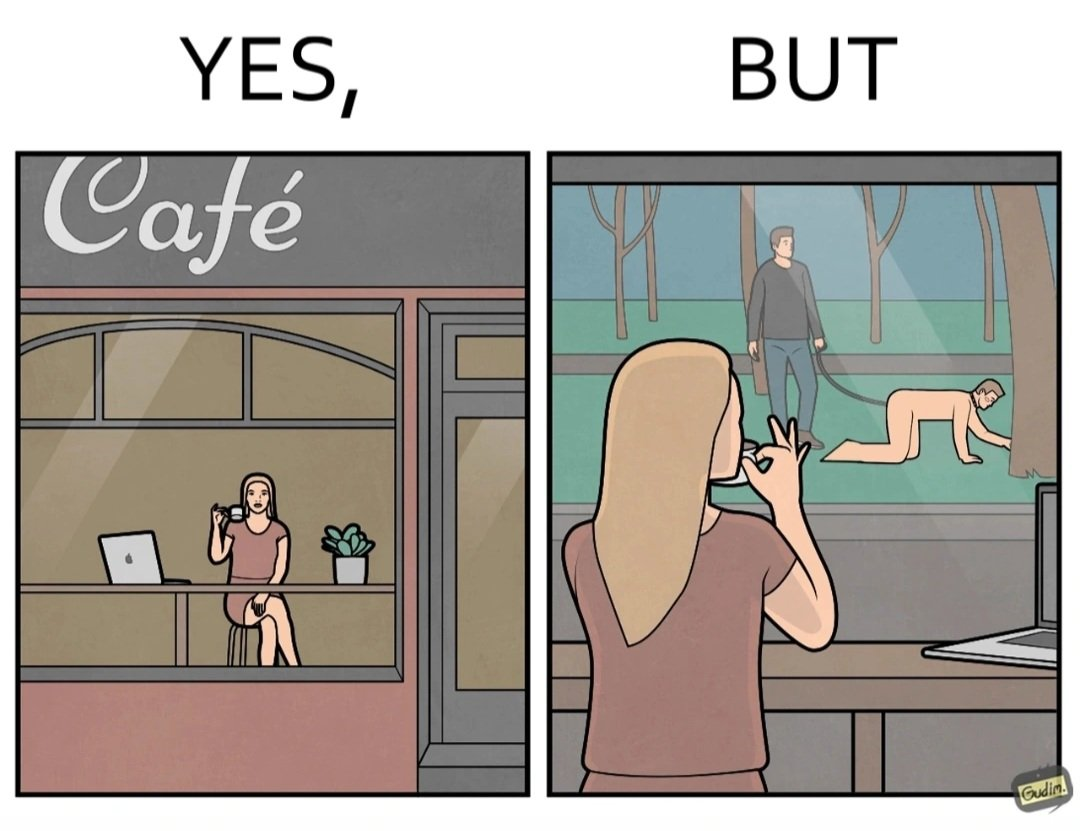Would you classify this image as satirical? Yes, this image is satirical. 